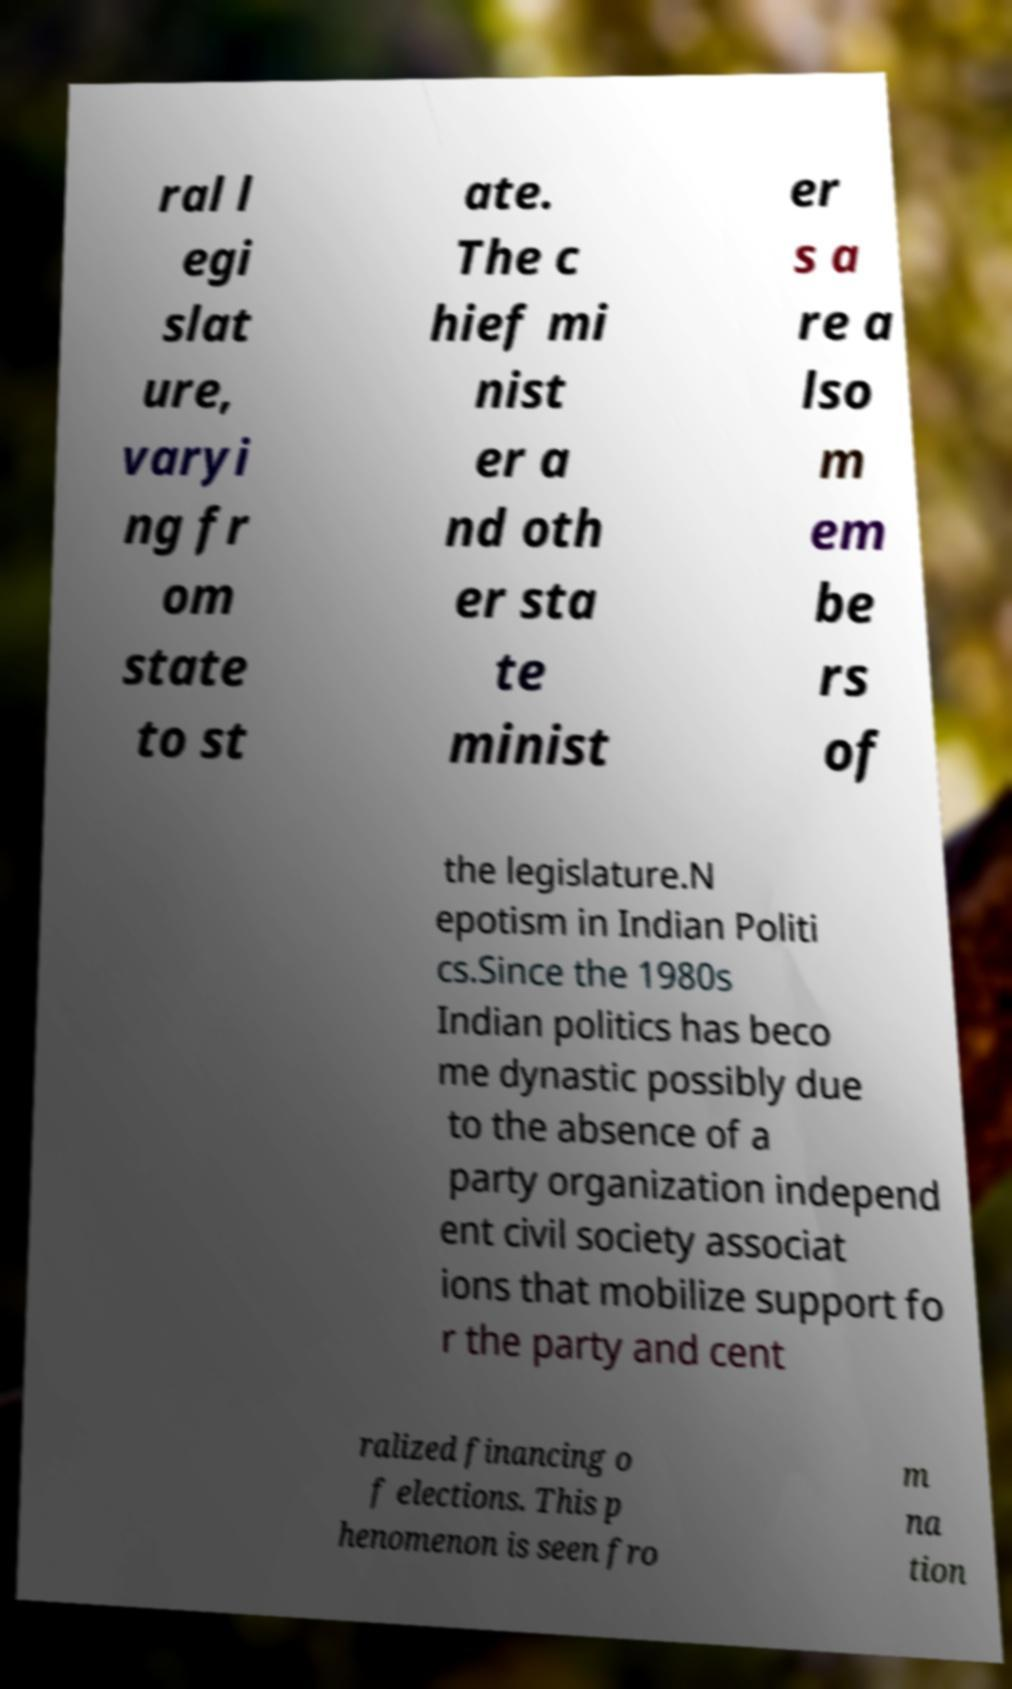Please identify and transcribe the text found in this image. ral l egi slat ure, varyi ng fr om state to st ate. The c hief mi nist er a nd oth er sta te minist er s a re a lso m em be rs of the legislature.N epotism in Indian Politi cs.Since the 1980s Indian politics has beco me dynastic possibly due to the absence of a party organization independ ent civil society associat ions that mobilize support fo r the party and cent ralized financing o f elections. This p henomenon is seen fro m na tion 